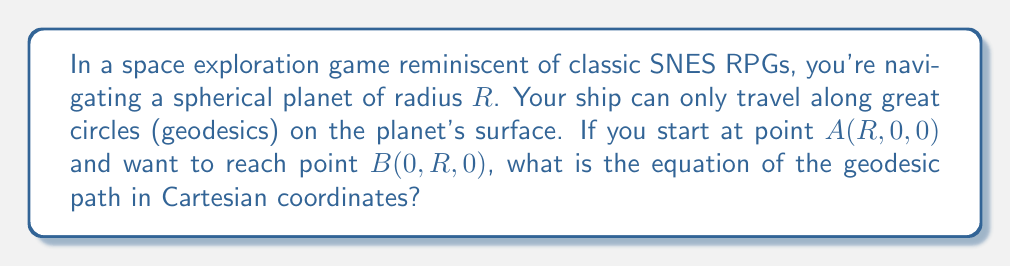Solve this math problem. Let's approach this step-by-step:

1) First, recall that on a sphere, geodesics are great circles. These are circles on the surface of the sphere whose centers coincide with the center of the sphere.

2) The sphere's equation in Cartesian coordinates is:

   $$x^2 + y^2 + z^2 = R^2$$

3) The plane containing both points A and B and the center of the sphere (0, 0, 0) will intersect the sphere along the geodesic we're looking for.

4) This plane can be described by the equation $z = ax + by$, where $a$ and $b$ are constants we need to determine.

5) Since both A(R, 0, 0) and B(0, R, 0) lie on this plane, we can conclude that $b = 0$ (because when $x = R$ and $y = 0$, $z$ must equal 0).

6) The plane equation simplifies to $z = ax$.

7) Substituting this into the sphere equation:

   $$x^2 + y^2 + (ax)^2 = R^2$$

8) Rearranging:

   $$x^2(1 + a^2) + y^2 = R^2$$

9) This is the equation of an ellipse in the xy-plane, which represents our geodesic path.

10) To determine $a$, we can use the fact that the path passes through B(0, R, 0). Substituting these coordinates into our equation:

    $$0^2(1 + a^2) + R^2 = R^2$$

    This is true for any value of $a$, so we can choose $a = 1$ for simplicity.

11) With $a = 1$, our final equation becomes:

    $$2x^2 + y^2 = R^2$$
Answer: $$2x^2 + y^2 = R^2$$ 